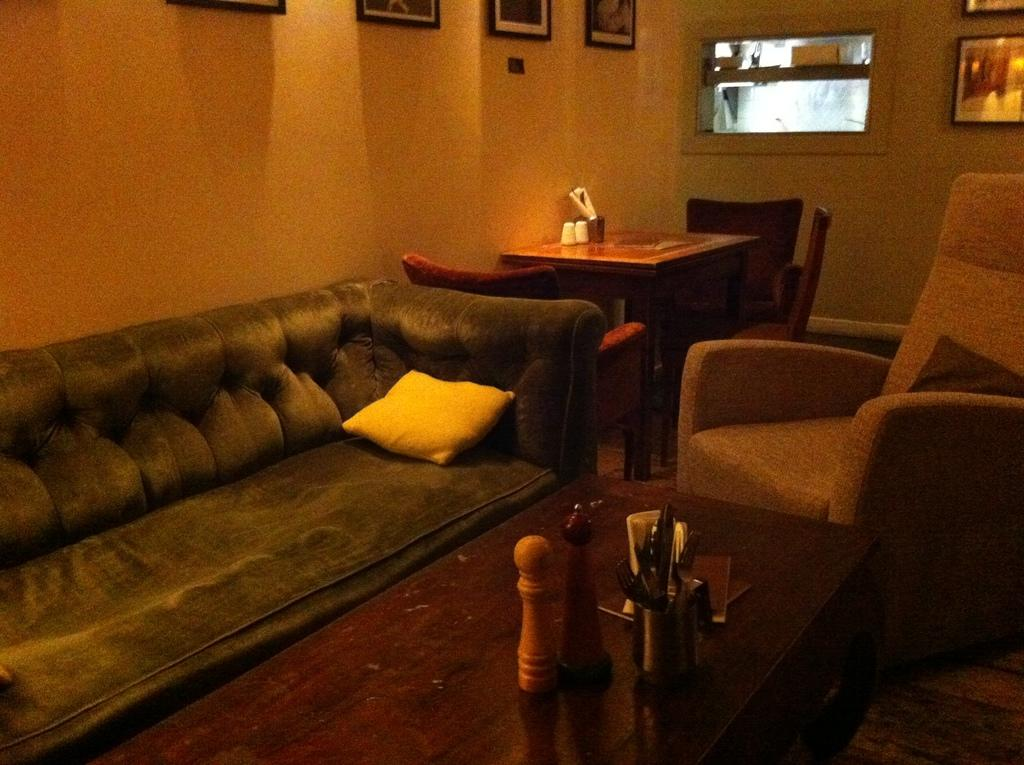What type of furniture is present in the image? There is a sofa and chairs in the image. How many tables are visible in the image? There are two tables in the image. What is on top of the tables? There are things on the tables. What can be seen in the background of the image? There is a wall in the background of the image. What is hanging on the wall? There are photo frames on the wall. What is the plot of the story unfolding on the sofa in the image? There is no story or plot depicted in the image; it is a still photograph of furniture and decor. 